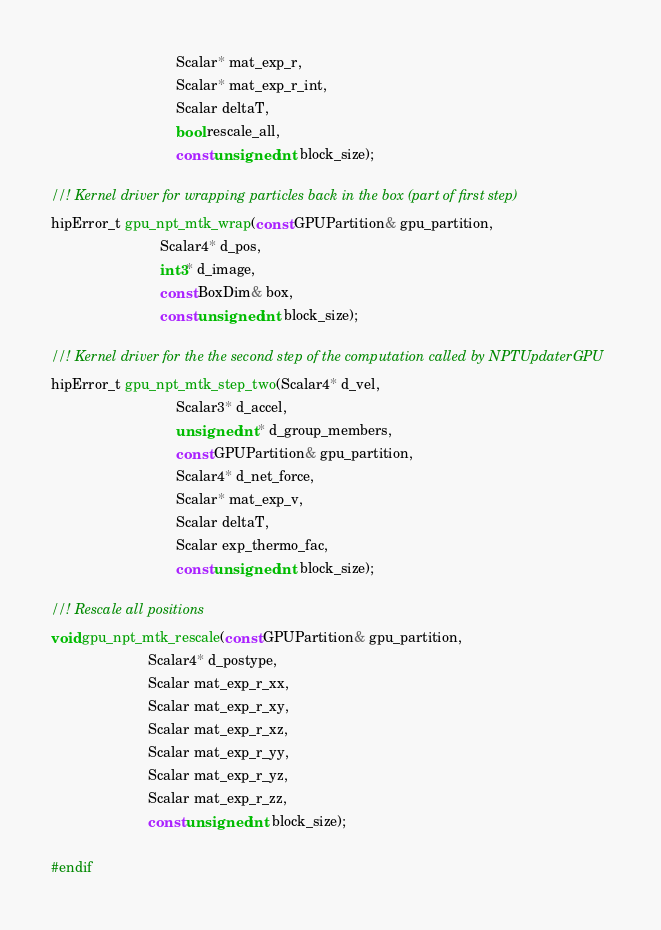<code> <loc_0><loc_0><loc_500><loc_500><_Cuda_>                                Scalar* mat_exp_r,
                                Scalar* mat_exp_r_int,
                                Scalar deltaT,
                                bool rescale_all,
                                const unsigned int block_size);

//! Kernel driver for wrapping particles back in the box (part of first step)
hipError_t gpu_npt_mtk_wrap(const GPUPartition& gpu_partition,
                            Scalar4* d_pos,
                            int3* d_image,
                            const BoxDim& box,
                            const unsigned int block_size);

//! Kernel driver for the the second step of the computation called by NPTUpdaterGPU
hipError_t gpu_npt_mtk_step_two(Scalar4* d_vel,
                                Scalar3* d_accel,
                                unsigned int* d_group_members,
                                const GPUPartition& gpu_partition,
                                Scalar4* d_net_force,
                                Scalar* mat_exp_v,
                                Scalar deltaT,
                                Scalar exp_thermo_fac,
                                const unsigned int block_size);

//! Rescale all positions
void gpu_npt_mtk_rescale(const GPUPartition& gpu_partition,
                         Scalar4* d_postype,
                         Scalar mat_exp_r_xx,
                         Scalar mat_exp_r_xy,
                         Scalar mat_exp_r_xz,
                         Scalar mat_exp_r_yy,
                         Scalar mat_exp_r_yz,
                         Scalar mat_exp_r_zz,
                         const unsigned int block_size);

#endif
</code> 